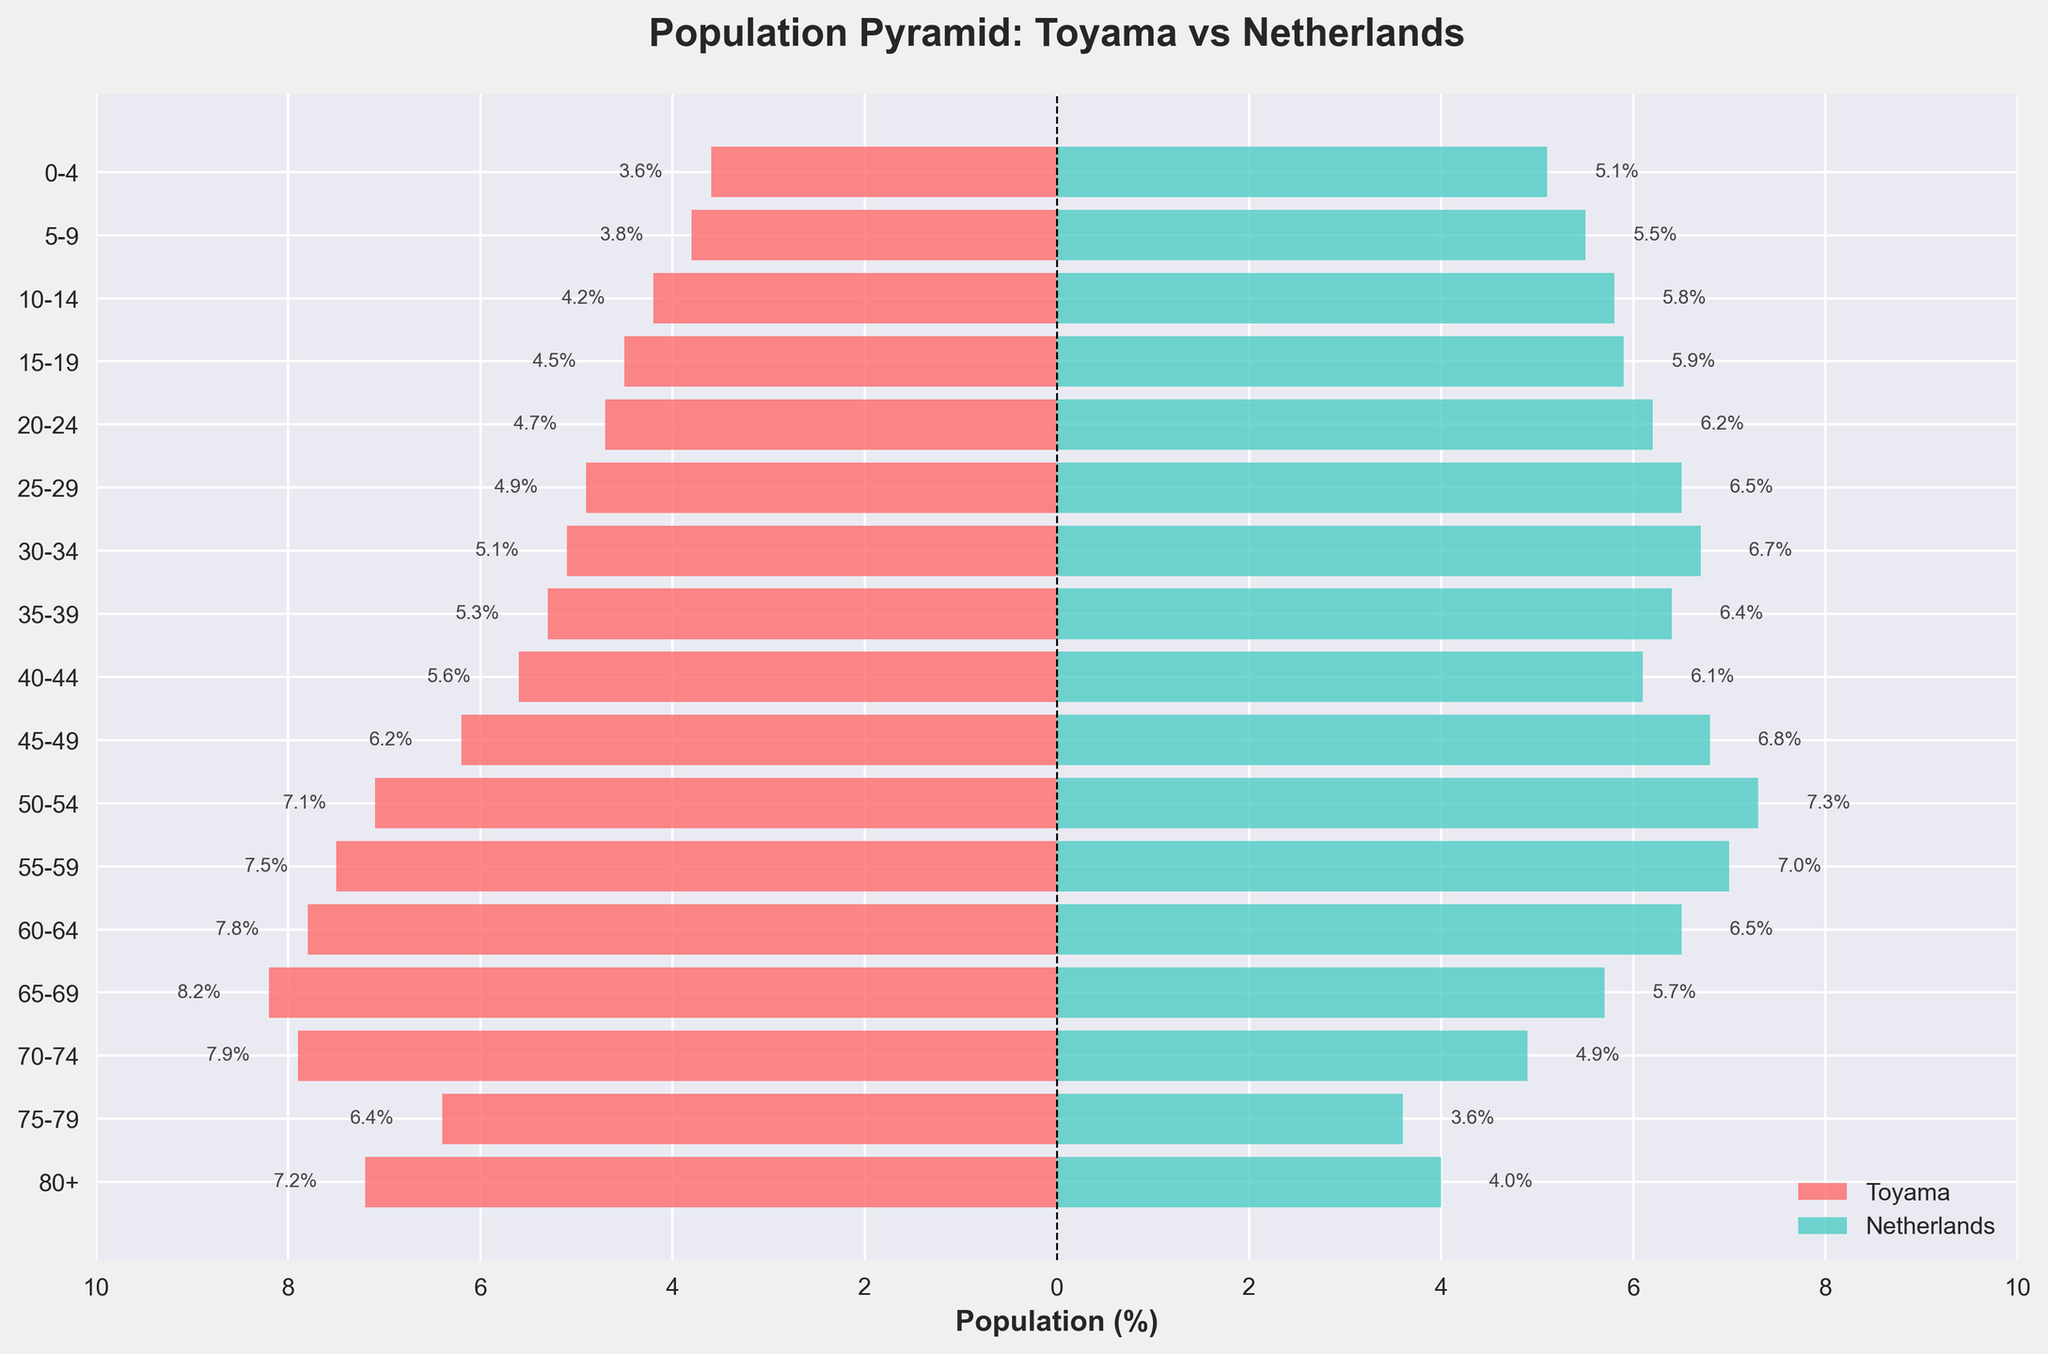Which place has a higher percentage of the 0-4 age group? Compare the percentages for the 0-4 age group between Toyama and the Netherlands. The Netherlands has 5.1% while Toyama has 3.6%.
Answer: Netherlands What is the title of the population pyramid? Look at the top of the figure to find the title. The title clearly states "Population Pyramid: Toyama vs Netherlands."
Answer: Population Pyramid: Toyama vs Netherlands How many age groups are compared in the figure? Count the y-axis labels representing different age groups. There are 17 age groups displayed in the figure.
Answer: 17 What is the age group with the highest percentage in Toyama? Scan through the negative bars representing Toyama to find the one with the highest absolute value. The 65-69 age group has the highest percentage at 8.2%.
Answer: 65-69 Which age group has the closest percentages between Toyama and the Netherlands? Compare the bars for both Toyama and the Netherlands to find the age group where the percentages are nearly equal. The 50-54 age group has Toyama at 7.1% and the Netherlands at 7.3%.
Answer: 50-54 What’s the difference in percentage for the 25-29 age group between Toyama and the Netherlands? Subtract the percentage of Toyama for the 25-29 age group from the percentage of the Netherlands for the same age group: 6.5% - 4.9% = 1.6%.
Answer: 1.6% What is the combined percentage of the working-age population (15-64) in Toyama? Sum the percentages for the 15-19, 20-24, 25-29, 30-34, 35-39, 40-44, 45-49, 50-54, 55-59, and 60-64 age groups for Toyama: 4.5% + 4.7% + 4.9% + 5.1% + 5.3% + 5.6% + 6.2% + 7.1% + 7.5% + 7.8% = 58.7%.
Answer: 58.7% Is the percentage of the population aged 80+ higher in Toyama or in the Netherlands? Compare the percentages of the 80+ age group between Toyama and the Netherlands. Toyama has 7.2% while the Netherlands has 4.0%.
Answer: Toyama Which country has a more even age distribution from 0-19 years? Look at the bars for age groups 0-4, 5-9, 10-14, and 15-19. The Netherlands shows a more even distribution with percentages ranging from 5.1% to 5.9%, whereas Toyama’s percentages range from 3.6% to 4.5%.
Answer: Netherlands How does the working-age population (15-64) in the Netherlands compare to Toyama? Calculate the sum for the working-age population in the Netherlands for 15-19, 20-24, 25-29, 30-34, 35-39, 40-44, 45-49, 50-54, 55-59, and 60-64: 5.9% + 6.2% + 6.5% + 6.7% + 6.4% + 6.1% + 6.8% + 7.3% + 7.0% + 6.5% = 65.4%. The combined population for Toyama in the same groups is 58.7%.
Answer: Netherlands 